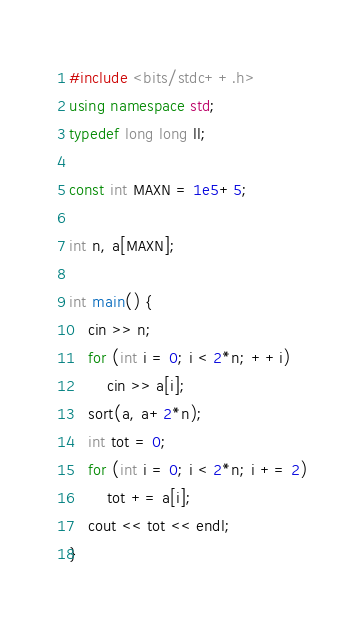<code> <loc_0><loc_0><loc_500><loc_500><_C++_>#include <bits/stdc++.h>
using namespace std;
typedef long long ll;

const int MAXN = 1e5+5;

int n, a[MAXN];

int main() {
	cin >> n;
	for (int i = 0; i < 2*n; ++i)
		cin >> a[i];
	sort(a, a+2*n);
	int tot = 0;
	for (int i = 0; i < 2*n; i += 2)
		tot += a[i];
	cout << tot << endl;
}</code> 